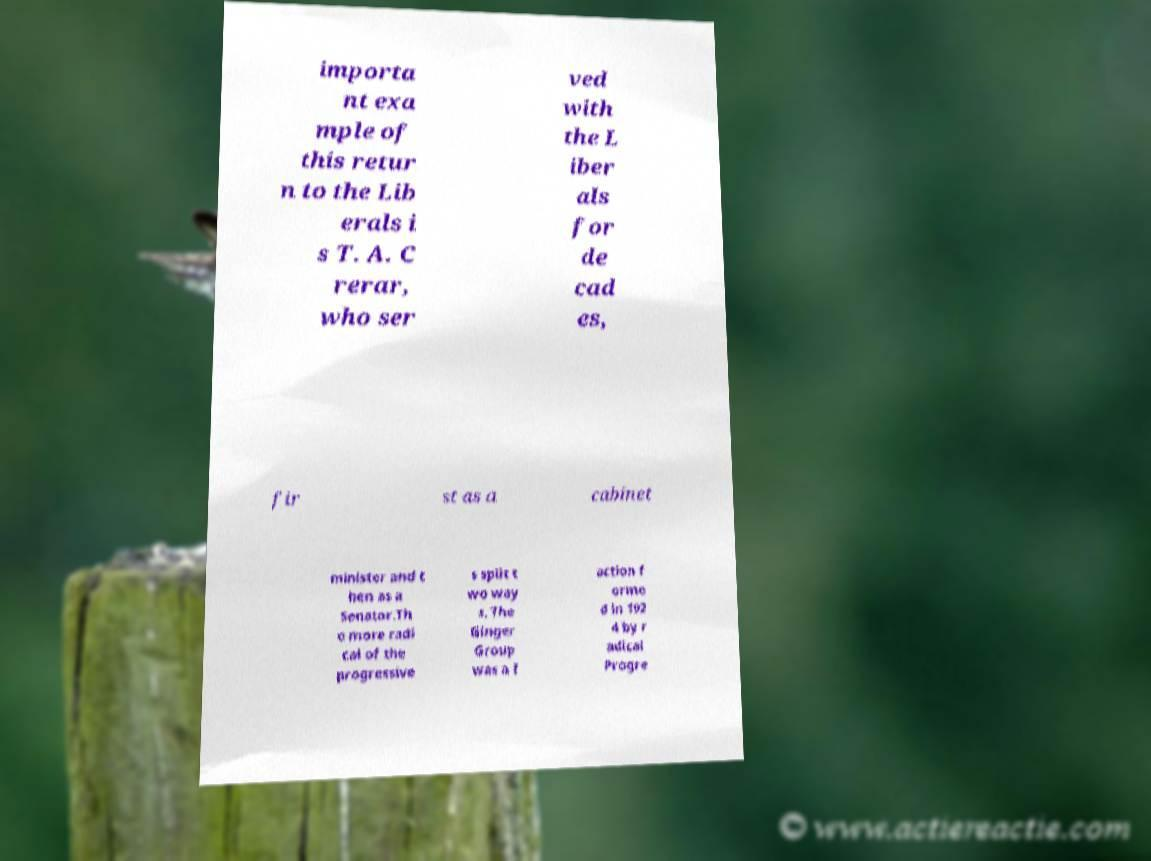I need the written content from this picture converted into text. Can you do that? importa nt exa mple of this retur n to the Lib erals i s T. A. C rerar, who ser ved with the L iber als for de cad es, fir st as a cabinet minister and t hen as a Senator.Th e more radi cal of the progressive s split t wo way s. The Ginger Group was a f action f orme d in 192 4 by r adical Progre 